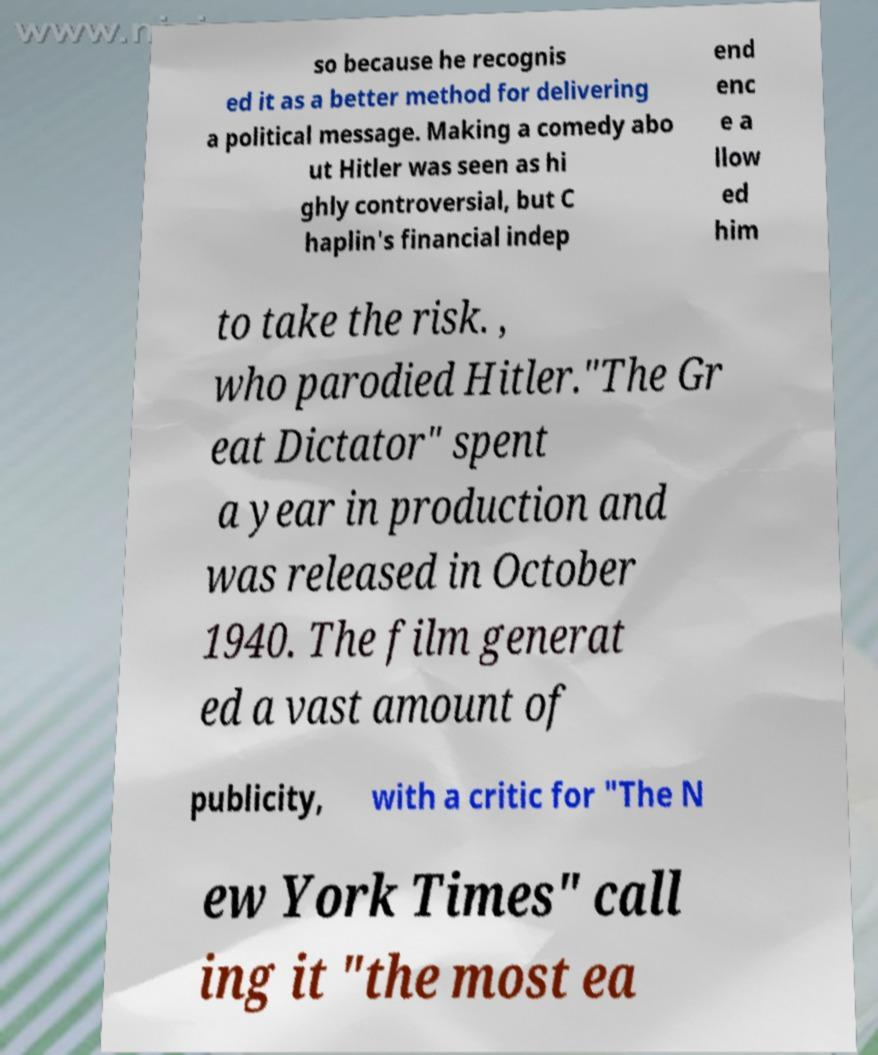Can you accurately transcribe the text from the provided image for me? so because he recognis ed it as a better method for delivering a political message. Making a comedy abo ut Hitler was seen as hi ghly controversial, but C haplin's financial indep end enc e a llow ed him to take the risk. , who parodied Hitler."The Gr eat Dictator" spent a year in production and was released in October 1940. The film generat ed a vast amount of publicity, with a critic for "The N ew York Times" call ing it "the most ea 